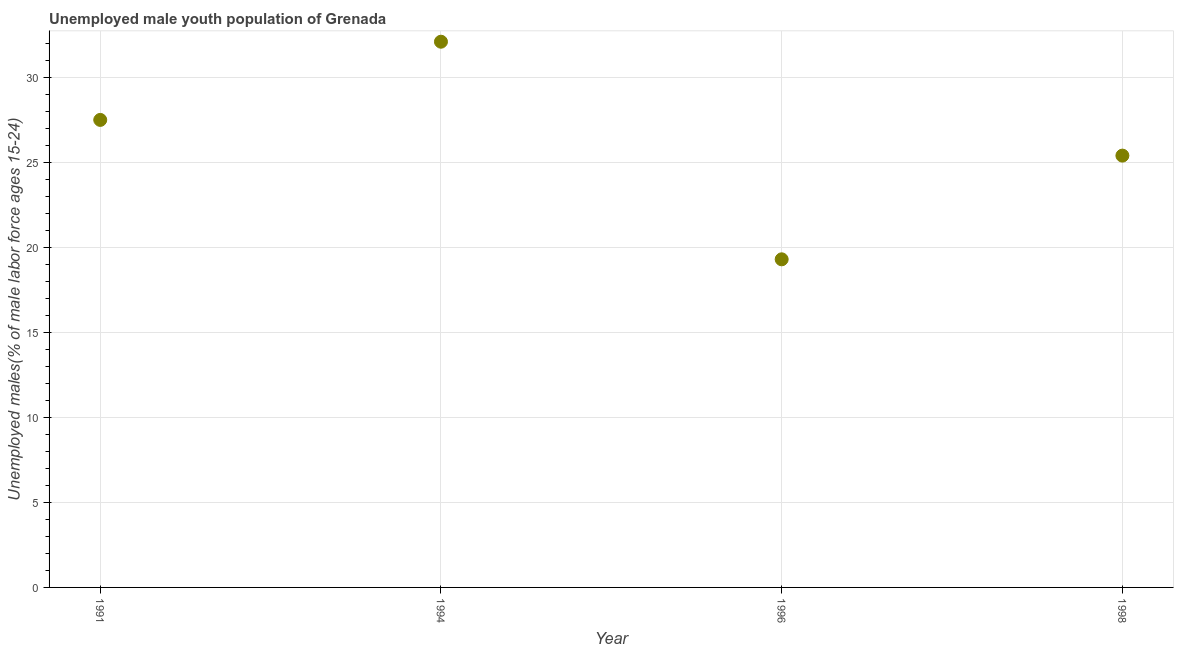What is the unemployed male youth in 1998?
Ensure brevity in your answer.  25.4. Across all years, what is the maximum unemployed male youth?
Your answer should be very brief. 32.1. Across all years, what is the minimum unemployed male youth?
Your answer should be compact. 19.3. In which year was the unemployed male youth maximum?
Your answer should be compact. 1994. What is the sum of the unemployed male youth?
Your response must be concise. 104.3. What is the difference between the unemployed male youth in 1991 and 1994?
Make the answer very short. -4.6. What is the average unemployed male youth per year?
Your response must be concise. 26.07. What is the median unemployed male youth?
Ensure brevity in your answer.  26.45. Do a majority of the years between 1996 and 1994 (inclusive) have unemployed male youth greater than 23 %?
Make the answer very short. No. What is the ratio of the unemployed male youth in 1994 to that in 1998?
Offer a terse response. 1.26. Is the unemployed male youth in 1994 less than that in 1998?
Provide a succinct answer. No. Is the difference between the unemployed male youth in 1991 and 1998 greater than the difference between any two years?
Your response must be concise. No. What is the difference between the highest and the second highest unemployed male youth?
Your response must be concise. 4.6. What is the difference between the highest and the lowest unemployed male youth?
Make the answer very short. 12.8. Does the unemployed male youth monotonically increase over the years?
Make the answer very short. No. How many dotlines are there?
Your response must be concise. 1. How many years are there in the graph?
Provide a succinct answer. 4. Are the values on the major ticks of Y-axis written in scientific E-notation?
Your answer should be very brief. No. Does the graph contain any zero values?
Make the answer very short. No. Does the graph contain grids?
Your answer should be very brief. Yes. What is the title of the graph?
Your answer should be compact. Unemployed male youth population of Grenada. What is the label or title of the X-axis?
Give a very brief answer. Year. What is the label or title of the Y-axis?
Provide a short and direct response. Unemployed males(% of male labor force ages 15-24). What is the Unemployed males(% of male labor force ages 15-24) in 1991?
Offer a very short reply. 27.5. What is the Unemployed males(% of male labor force ages 15-24) in 1994?
Your answer should be very brief. 32.1. What is the Unemployed males(% of male labor force ages 15-24) in 1996?
Your answer should be very brief. 19.3. What is the Unemployed males(% of male labor force ages 15-24) in 1998?
Ensure brevity in your answer.  25.4. What is the difference between the Unemployed males(% of male labor force ages 15-24) in 1991 and 1994?
Ensure brevity in your answer.  -4.6. What is the difference between the Unemployed males(% of male labor force ages 15-24) in 1991 and 1996?
Offer a terse response. 8.2. What is the difference between the Unemployed males(% of male labor force ages 15-24) in 1994 and 1996?
Your response must be concise. 12.8. What is the ratio of the Unemployed males(% of male labor force ages 15-24) in 1991 to that in 1994?
Your answer should be very brief. 0.86. What is the ratio of the Unemployed males(% of male labor force ages 15-24) in 1991 to that in 1996?
Ensure brevity in your answer.  1.43. What is the ratio of the Unemployed males(% of male labor force ages 15-24) in 1991 to that in 1998?
Your answer should be very brief. 1.08. What is the ratio of the Unemployed males(% of male labor force ages 15-24) in 1994 to that in 1996?
Your response must be concise. 1.66. What is the ratio of the Unemployed males(% of male labor force ages 15-24) in 1994 to that in 1998?
Give a very brief answer. 1.26. What is the ratio of the Unemployed males(% of male labor force ages 15-24) in 1996 to that in 1998?
Your answer should be very brief. 0.76. 